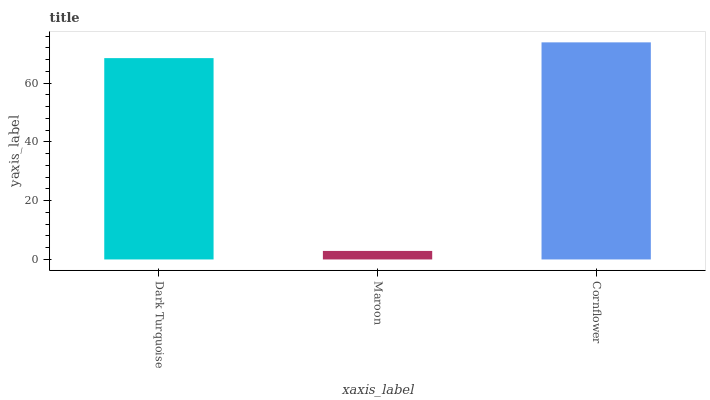Is Cornflower the minimum?
Answer yes or no. No. Is Maroon the maximum?
Answer yes or no. No. Is Cornflower greater than Maroon?
Answer yes or no. Yes. Is Maroon less than Cornflower?
Answer yes or no. Yes. Is Maroon greater than Cornflower?
Answer yes or no. No. Is Cornflower less than Maroon?
Answer yes or no. No. Is Dark Turquoise the high median?
Answer yes or no. Yes. Is Dark Turquoise the low median?
Answer yes or no. Yes. Is Maroon the high median?
Answer yes or no. No. Is Maroon the low median?
Answer yes or no. No. 